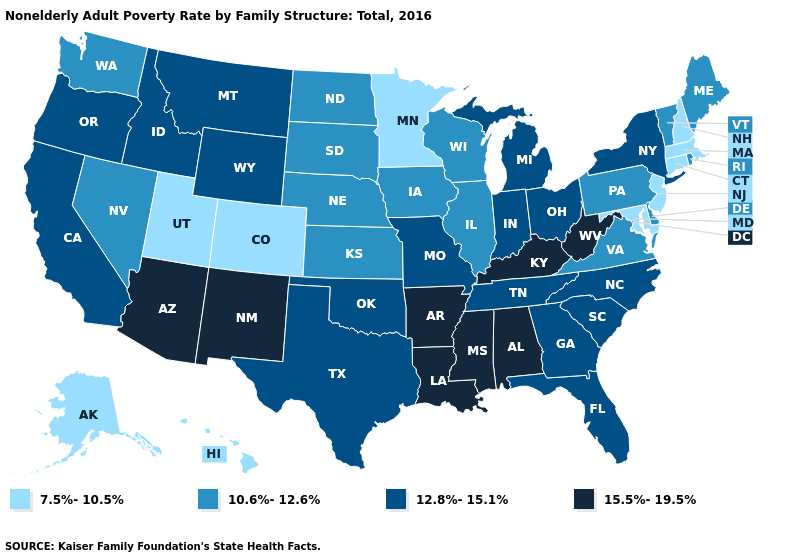Name the states that have a value in the range 15.5%-19.5%?
Keep it brief. Alabama, Arizona, Arkansas, Kentucky, Louisiana, Mississippi, New Mexico, West Virginia. Name the states that have a value in the range 7.5%-10.5%?
Keep it brief. Alaska, Colorado, Connecticut, Hawaii, Maryland, Massachusetts, Minnesota, New Hampshire, New Jersey, Utah. Does Louisiana have a higher value than Connecticut?
Concise answer only. Yes. What is the value of Hawaii?
Short answer required. 7.5%-10.5%. Does the first symbol in the legend represent the smallest category?
Write a very short answer. Yes. Does the map have missing data?
Short answer required. No. Name the states that have a value in the range 12.8%-15.1%?
Keep it brief. California, Florida, Georgia, Idaho, Indiana, Michigan, Missouri, Montana, New York, North Carolina, Ohio, Oklahoma, Oregon, South Carolina, Tennessee, Texas, Wyoming. Which states have the highest value in the USA?
Short answer required. Alabama, Arizona, Arkansas, Kentucky, Louisiana, Mississippi, New Mexico, West Virginia. Does the map have missing data?
Write a very short answer. No. Name the states that have a value in the range 12.8%-15.1%?
Write a very short answer. California, Florida, Georgia, Idaho, Indiana, Michigan, Missouri, Montana, New York, North Carolina, Ohio, Oklahoma, Oregon, South Carolina, Tennessee, Texas, Wyoming. Among the states that border Texas , does Oklahoma have the highest value?
Short answer required. No. What is the value of California?
Keep it brief. 12.8%-15.1%. What is the lowest value in the USA?
Answer briefly. 7.5%-10.5%. Does Arizona have the highest value in the West?
Be succinct. Yes. Name the states that have a value in the range 7.5%-10.5%?
Quick response, please. Alaska, Colorado, Connecticut, Hawaii, Maryland, Massachusetts, Minnesota, New Hampshire, New Jersey, Utah. 